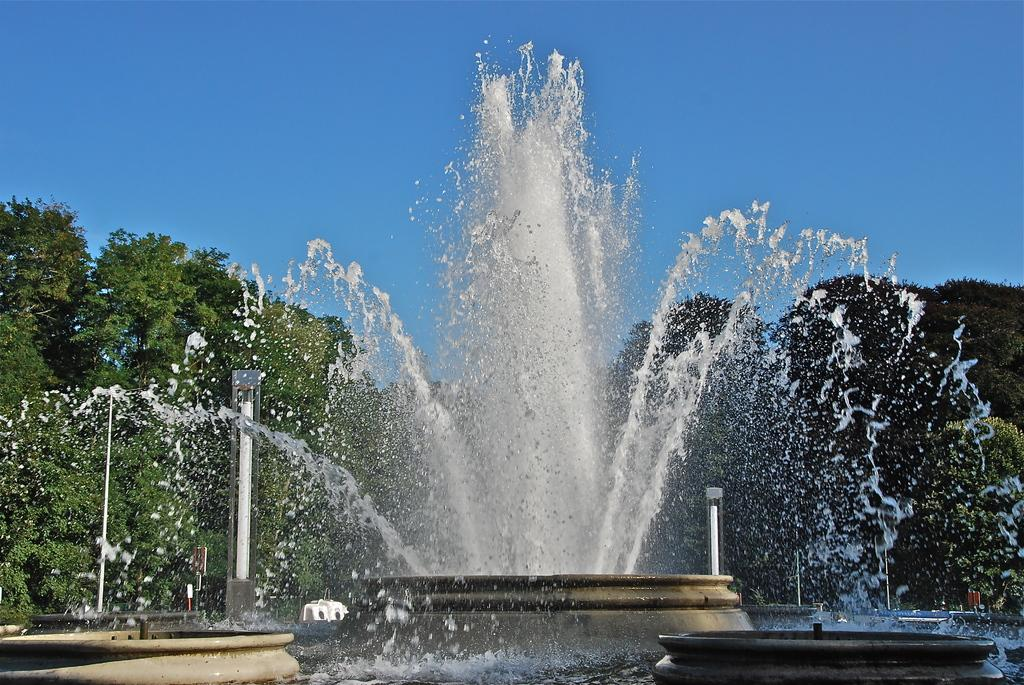What is the main feature in the center of the image? There is a fountain in the center of the image. What can be seen in the background of the image? There are trees and light poles in the background of the image. What is visible at the top of the image? The sky is visible at the top of the image. What type of education does the father receive on the farm in the image? There is no father or farm present in the image; it features a fountain, trees, light poles, and the sky. 